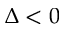<formula> <loc_0><loc_0><loc_500><loc_500>\Delta < 0</formula> 